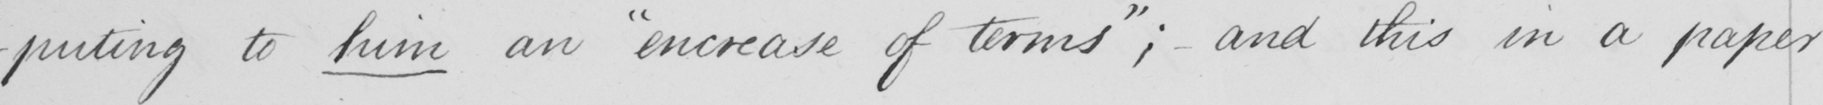What does this handwritten line say? -puting to him an  " increase of terms "  ; and this in a paper 